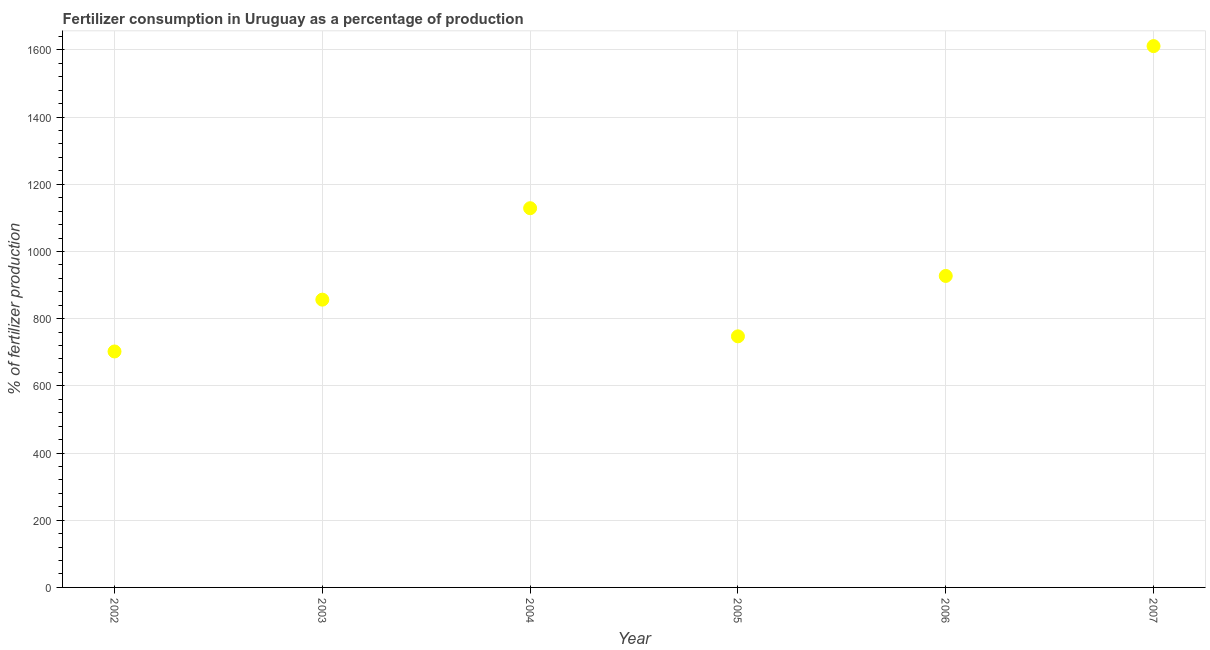What is the amount of fertilizer consumption in 2006?
Your answer should be very brief. 927.16. Across all years, what is the maximum amount of fertilizer consumption?
Give a very brief answer. 1611.26. Across all years, what is the minimum amount of fertilizer consumption?
Your response must be concise. 702.32. In which year was the amount of fertilizer consumption maximum?
Make the answer very short. 2007. What is the sum of the amount of fertilizer consumption?
Your response must be concise. 5973.41. What is the difference between the amount of fertilizer consumption in 2003 and 2005?
Make the answer very short. 109.19. What is the average amount of fertilizer consumption per year?
Offer a terse response. 995.57. What is the median amount of fertilizer consumption?
Make the answer very short. 891.86. In how many years, is the amount of fertilizer consumption greater than 1240 %?
Offer a very short reply. 1. What is the ratio of the amount of fertilizer consumption in 2006 to that in 2007?
Keep it short and to the point. 0.58. Is the amount of fertilizer consumption in 2004 less than that in 2006?
Give a very brief answer. No. Is the difference between the amount of fertilizer consumption in 2004 and 2005 greater than the difference between any two years?
Keep it short and to the point. No. What is the difference between the highest and the second highest amount of fertilizer consumption?
Your answer should be very brief. 482.52. What is the difference between the highest and the lowest amount of fertilizer consumption?
Your answer should be compact. 908.94. In how many years, is the amount of fertilizer consumption greater than the average amount of fertilizer consumption taken over all years?
Provide a short and direct response. 2. Does the amount of fertilizer consumption monotonically increase over the years?
Provide a succinct answer. No. How many dotlines are there?
Provide a short and direct response. 1. What is the difference between two consecutive major ticks on the Y-axis?
Offer a very short reply. 200. Does the graph contain grids?
Provide a short and direct response. Yes. What is the title of the graph?
Your answer should be compact. Fertilizer consumption in Uruguay as a percentage of production. What is the label or title of the X-axis?
Make the answer very short. Year. What is the label or title of the Y-axis?
Your answer should be very brief. % of fertilizer production. What is the % of fertilizer production in 2002?
Your answer should be compact. 702.32. What is the % of fertilizer production in 2003?
Keep it short and to the point. 856.56. What is the % of fertilizer production in 2004?
Ensure brevity in your answer.  1128.74. What is the % of fertilizer production in 2005?
Your answer should be very brief. 747.37. What is the % of fertilizer production in 2006?
Ensure brevity in your answer.  927.16. What is the % of fertilizer production in 2007?
Offer a very short reply. 1611.26. What is the difference between the % of fertilizer production in 2002 and 2003?
Ensure brevity in your answer.  -154.25. What is the difference between the % of fertilizer production in 2002 and 2004?
Offer a very short reply. -426.43. What is the difference between the % of fertilizer production in 2002 and 2005?
Make the answer very short. -45.05. What is the difference between the % of fertilizer production in 2002 and 2006?
Ensure brevity in your answer.  -224.84. What is the difference between the % of fertilizer production in 2002 and 2007?
Your response must be concise. -908.94. What is the difference between the % of fertilizer production in 2003 and 2004?
Provide a succinct answer. -272.18. What is the difference between the % of fertilizer production in 2003 and 2005?
Provide a short and direct response. 109.19. What is the difference between the % of fertilizer production in 2003 and 2006?
Ensure brevity in your answer.  -70.59. What is the difference between the % of fertilizer production in 2003 and 2007?
Provide a short and direct response. -754.7. What is the difference between the % of fertilizer production in 2004 and 2005?
Keep it short and to the point. 381.37. What is the difference between the % of fertilizer production in 2004 and 2006?
Provide a succinct answer. 201.59. What is the difference between the % of fertilizer production in 2004 and 2007?
Provide a short and direct response. -482.52. What is the difference between the % of fertilizer production in 2005 and 2006?
Make the answer very short. -179.79. What is the difference between the % of fertilizer production in 2005 and 2007?
Ensure brevity in your answer.  -863.89. What is the difference between the % of fertilizer production in 2006 and 2007?
Make the answer very short. -684.1. What is the ratio of the % of fertilizer production in 2002 to that in 2003?
Ensure brevity in your answer.  0.82. What is the ratio of the % of fertilizer production in 2002 to that in 2004?
Keep it short and to the point. 0.62. What is the ratio of the % of fertilizer production in 2002 to that in 2006?
Your answer should be very brief. 0.76. What is the ratio of the % of fertilizer production in 2002 to that in 2007?
Offer a terse response. 0.44. What is the ratio of the % of fertilizer production in 2003 to that in 2004?
Your answer should be very brief. 0.76. What is the ratio of the % of fertilizer production in 2003 to that in 2005?
Ensure brevity in your answer.  1.15. What is the ratio of the % of fertilizer production in 2003 to that in 2006?
Offer a very short reply. 0.92. What is the ratio of the % of fertilizer production in 2003 to that in 2007?
Provide a short and direct response. 0.53. What is the ratio of the % of fertilizer production in 2004 to that in 2005?
Provide a short and direct response. 1.51. What is the ratio of the % of fertilizer production in 2004 to that in 2006?
Keep it short and to the point. 1.22. What is the ratio of the % of fertilizer production in 2004 to that in 2007?
Your answer should be very brief. 0.7. What is the ratio of the % of fertilizer production in 2005 to that in 2006?
Provide a short and direct response. 0.81. What is the ratio of the % of fertilizer production in 2005 to that in 2007?
Keep it short and to the point. 0.46. What is the ratio of the % of fertilizer production in 2006 to that in 2007?
Provide a short and direct response. 0.57. 